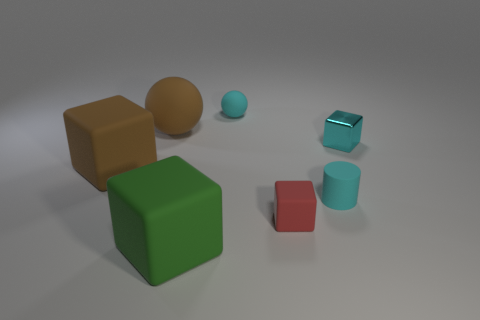How is the lighting arranged in this scene? The lighting appears to be ambient and diffused, with a directionality coming from the upper left, as indicated by the soft shadows cast on the right sides of the objects.  Does this lighting affect the perception of colors? Yes, the lighting can influence the perception of colors. In a diffused lighting environment, colors may appear more flat and less vibrant, as opposed to direct lighting which can create deeper shadows and highlights, potentially enhancing color contrast. 